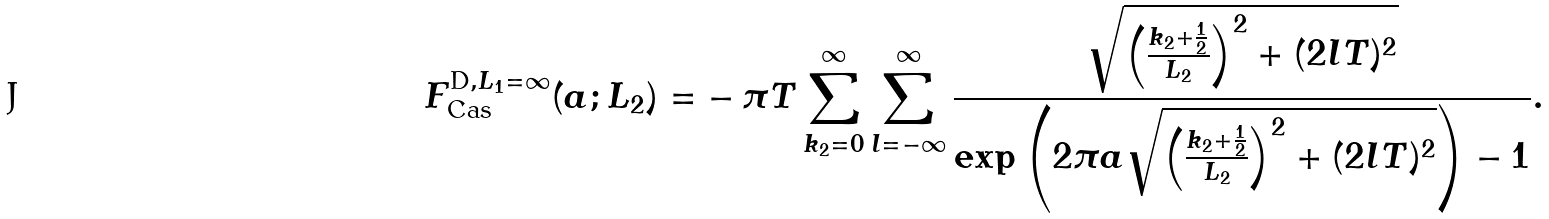<formula> <loc_0><loc_0><loc_500><loc_500>F _ { \text {Cas} } ^ { \text {D} , L _ { 1 } = \infty } ( a ; L _ { 2 } ) = & - \pi T \sum _ { k _ { 2 } = 0 } ^ { \infty } \sum _ { l = - \infty } ^ { \infty } \frac { \sqrt { \left ( \frac { k _ { 2 } + \frac { 1 } { 2 } } { L _ { 2 } } \right ) ^ { 2 } + ( 2 l T ) ^ { 2 } } } { \exp \left ( 2 \pi a \sqrt { \left ( \frac { k _ { 2 } + \frac { 1 } { 2 } } { L _ { 2 } } \right ) ^ { 2 } + ( 2 l T ) ^ { 2 } } \right ) - 1 } .</formula> 